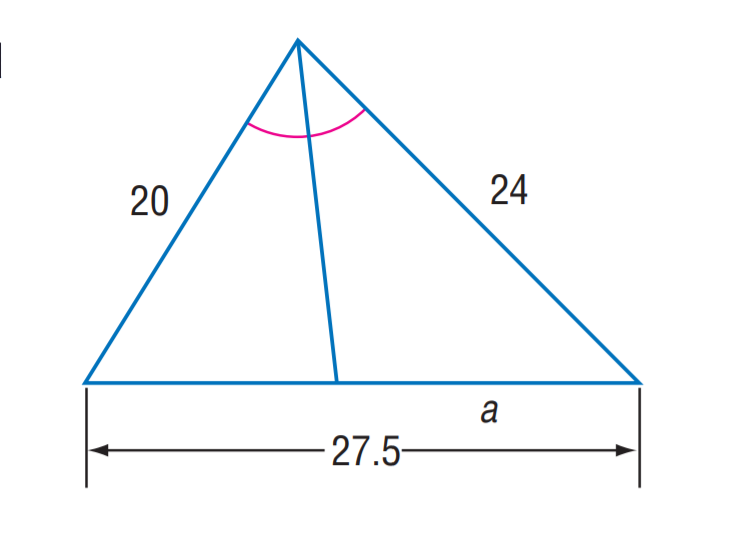Answer the mathemtical geometry problem and directly provide the correct option letter.
Question: Find a.
Choices: A: 12 B: 12.5 C: 15 D: 17.5 C 